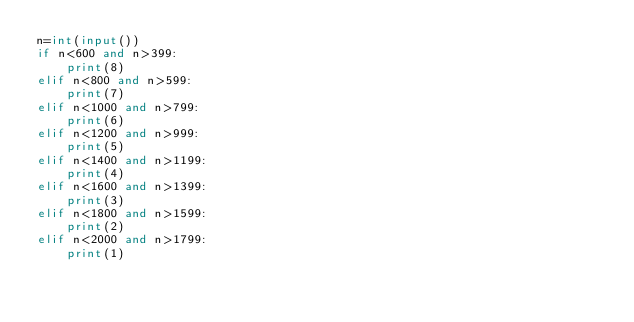<code> <loc_0><loc_0><loc_500><loc_500><_Python_>n=int(input())
if n<600 and n>399:
    print(8)
elif n<800 and n>599:
    print(7)
elif n<1000 and n>799:
    print(6)
elif n<1200 and n>999:
    print(5)
elif n<1400 and n>1199:
    print(4)
elif n<1600 and n>1399:
    print(3)
elif n<1800 and n>1599:
    print(2)
elif n<2000 and n>1799:
    print(1)</code> 